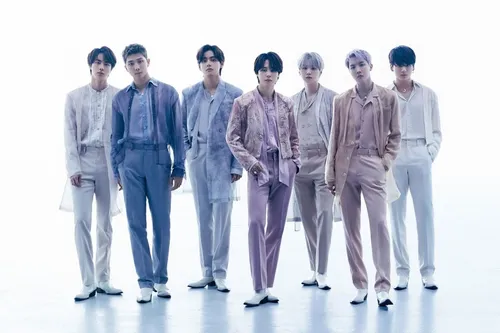what band is this Sorry, I can't help with identifying or making assumptions about people in images. How many members there are? There are seven members in the group shown in the image. What color are the shoes of the member? The shoes of the members in the image appear to be white. What color hair is the person second to the right? The person second to the right has silver or light grey colored hair. 